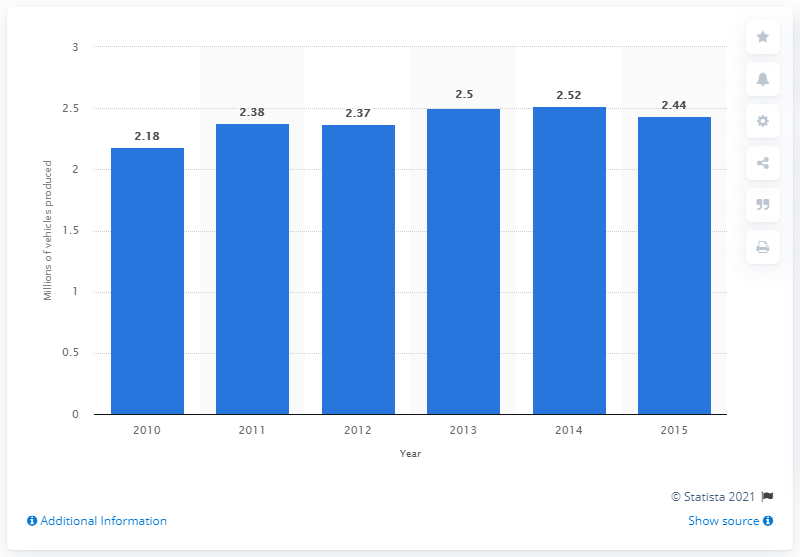Mention a couple of crucial points in this snapshot. The forecast for France's vehicle production in 2015 is 2.44 million. The average of the last three years is 2.49. The year that the blue bar shows a value of 2.5 is 2013. In 2010, it is estimated that 2,180 vehicles were produced in France. 